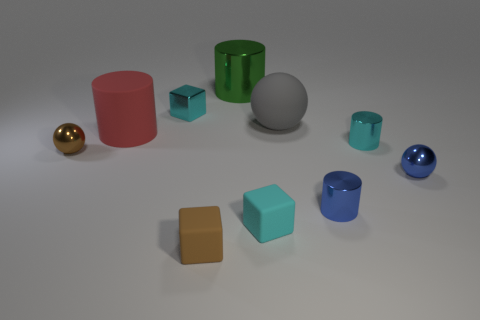Subtract all green cylinders. How many cylinders are left? 3 Subtract all gray cylinders. How many cyan blocks are left? 2 Subtract 1 cylinders. How many cylinders are left? 3 Subtract all cyan cylinders. How many cylinders are left? 3 Subtract all blocks. How many objects are left? 7 Subtract all gray blocks. Subtract all brown cylinders. How many blocks are left? 3 Subtract all red objects. Subtract all large green metallic cylinders. How many objects are left? 8 Add 6 tiny brown objects. How many tiny brown objects are left? 8 Add 1 brown rubber things. How many brown rubber things exist? 2 Subtract 0 yellow balls. How many objects are left? 10 